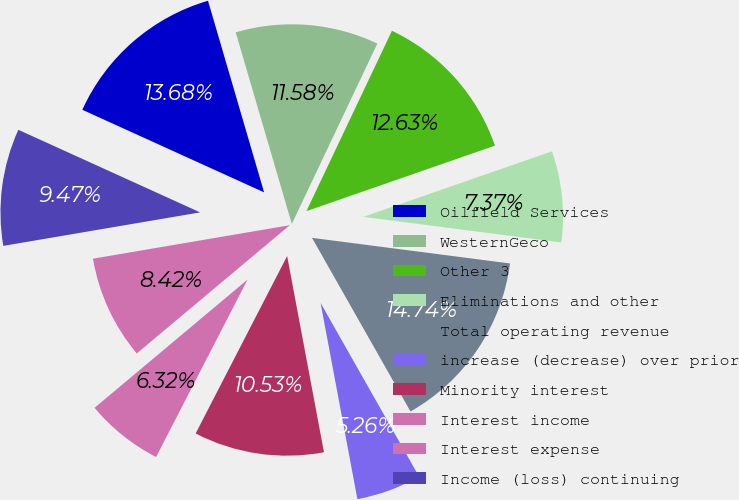Convert chart to OTSL. <chart><loc_0><loc_0><loc_500><loc_500><pie_chart><fcel>Oilfield Services<fcel>WesternGeco<fcel>Other 3<fcel>Eliminations and other<fcel>Total operating revenue<fcel>increase (decrease) over prior<fcel>Minority interest<fcel>Interest income<fcel>Interest expense<fcel>Income (loss) continuing<nl><fcel>13.68%<fcel>11.58%<fcel>12.63%<fcel>7.37%<fcel>14.74%<fcel>5.26%<fcel>10.53%<fcel>6.32%<fcel>8.42%<fcel>9.47%<nl></chart> 